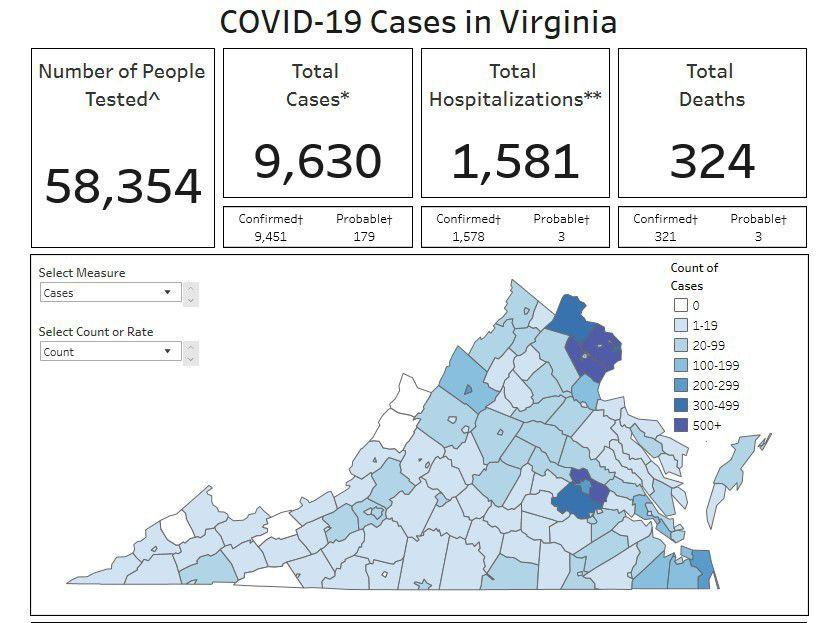List a handful of essential elements in this visual. According to official data, a total of 1,578 confirmed COVID-19 cases in Virginia were hospitalized as of a specific date. The Virginia Department of Health tested a total of 58,354 individuals for COVID-19 as of April 14, 2022. A preliminary estimate suggests that there may have been approximately 3 COVID-19 deaths in Virginia. As of today, there have been a confirmed 9,451 cases of COVID-19 in the state of Virginia. According to the latest data, a total of 9,630 COVID-19 cases have been reported in Virginia as of [insert date]. 